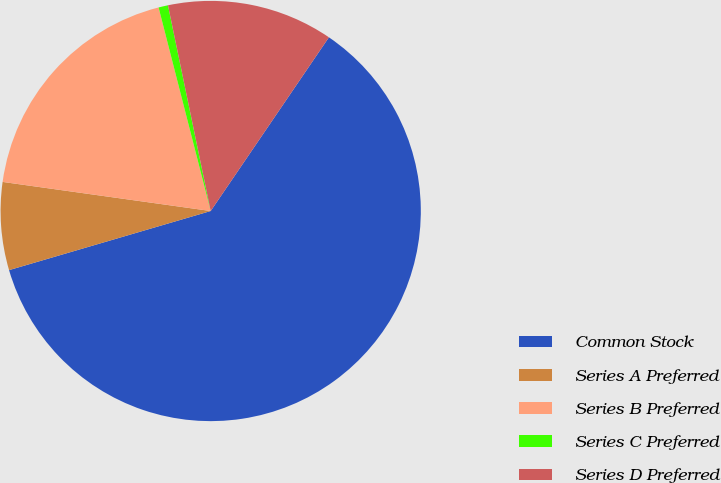Convert chart to OTSL. <chart><loc_0><loc_0><loc_500><loc_500><pie_chart><fcel>Common Stock<fcel>Series A Preferred<fcel>Series B Preferred<fcel>Series C Preferred<fcel>Series D Preferred<nl><fcel>60.95%<fcel>6.75%<fcel>18.8%<fcel>0.73%<fcel>12.77%<nl></chart> 